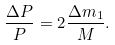<formula> <loc_0><loc_0><loc_500><loc_500>\frac { \Delta P } { P } = 2 \frac { \Delta m _ { 1 } } { M } .</formula> 